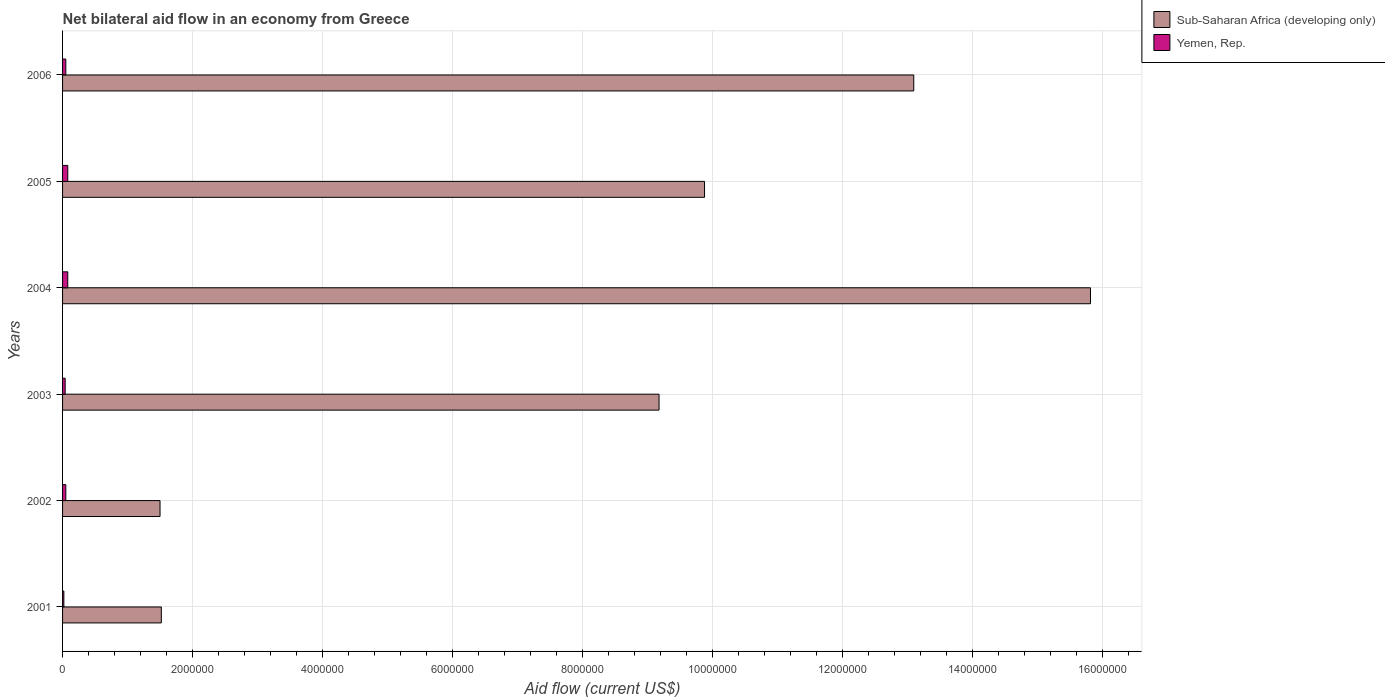How many different coloured bars are there?
Keep it short and to the point. 2. How many groups of bars are there?
Offer a terse response. 6. Are the number of bars per tick equal to the number of legend labels?
Provide a succinct answer. Yes. Are the number of bars on each tick of the Y-axis equal?
Provide a succinct answer. Yes. How many bars are there on the 4th tick from the top?
Your answer should be compact. 2. What is the label of the 1st group of bars from the top?
Provide a succinct answer. 2006. In how many cases, is the number of bars for a given year not equal to the number of legend labels?
Provide a succinct answer. 0. What is the net bilateral aid flow in Yemen, Rep. in 2006?
Offer a very short reply. 5.00e+04. Across all years, what is the maximum net bilateral aid flow in Sub-Saharan Africa (developing only)?
Your answer should be very brief. 1.58e+07. Across all years, what is the minimum net bilateral aid flow in Yemen, Rep.?
Your answer should be very brief. 2.00e+04. In which year was the net bilateral aid flow in Sub-Saharan Africa (developing only) maximum?
Offer a terse response. 2004. In which year was the net bilateral aid flow in Sub-Saharan Africa (developing only) minimum?
Your answer should be compact. 2002. What is the total net bilateral aid flow in Sub-Saharan Africa (developing only) in the graph?
Your answer should be compact. 5.10e+07. What is the difference between the net bilateral aid flow in Sub-Saharan Africa (developing only) in 2002 and that in 2003?
Provide a succinct answer. -7.68e+06. What is the difference between the net bilateral aid flow in Sub-Saharan Africa (developing only) in 2001 and the net bilateral aid flow in Yemen, Rep. in 2003?
Ensure brevity in your answer.  1.48e+06. What is the average net bilateral aid flow in Yemen, Rep. per year?
Keep it short and to the point. 5.33e+04. In the year 2002, what is the difference between the net bilateral aid flow in Yemen, Rep. and net bilateral aid flow in Sub-Saharan Africa (developing only)?
Ensure brevity in your answer.  -1.45e+06. What is the ratio of the net bilateral aid flow in Sub-Saharan Africa (developing only) in 2004 to that in 2006?
Keep it short and to the point. 1.21. Is the net bilateral aid flow in Yemen, Rep. in 2001 less than that in 2002?
Offer a very short reply. Yes. What is the difference between the highest and the second highest net bilateral aid flow in Yemen, Rep.?
Offer a very short reply. 0. Is the sum of the net bilateral aid flow in Sub-Saharan Africa (developing only) in 2003 and 2005 greater than the maximum net bilateral aid flow in Yemen, Rep. across all years?
Keep it short and to the point. Yes. What does the 1st bar from the top in 2004 represents?
Your answer should be very brief. Yemen, Rep. What does the 1st bar from the bottom in 2002 represents?
Provide a succinct answer. Sub-Saharan Africa (developing only). Are all the bars in the graph horizontal?
Give a very brief answer. Yes. How many years are there in the graph?
Keep it short and to the point. 6. What is the difference between two consecutive major ticks on the X-axis?
Offer a terse response. 2.00e+06. What is the title of the graph?
Provide a short and direct response. Net bilateral aid flow in an economy from Greece. Does "Venezuela" appear as one of the legend labels in the graph?
Provide a succinct answer. No. What is the label or title of the Y-axis?
Offer a terse response. Years. What is the Aid flow (current US$) in Sub-Saharan Africa (developing only) in 2001?
Provide a succinct answer. 1.52e+06. What is the Aid flow (current US$) in Sub-Saharan Africa (developing only) in 2002?
Keep it short and to the point. 1.50e+06. What is the Aid flow (current US$) in Sub-Saharan Africa (developing only) in 2003?
Your response must be concise. 9.18e+06. What is the Aid flow (current US$) in Sub-Saharan Africa (developing only) in 2004?
Provide a short and direct response. 1.58e+07. What is the Aid flow (current US$) of Sub-Saharan Africa (developing only) in 2005?
Your response must be concise. 9.88e+06. What is the Aid flow (current US$) in Sub-Saharan Africa (developing only) in 2006?
Your answer should be very brief. 1.31e+07. What is the Aid flow (current US$) in Yemen, Rep. in 2006?
Give a very brief answer. 5.00e+04. Across all years, what is the maximum Aid flow (current US$) in Sub-Saharan Africa (developing only)?
Your answer should be very brief. 1.58e+07. Across all years, what is the maximum Aid flow (current US$) of Yemen, Rep.?
Ensure brevity in your answer.  8.00e+04. Across all years, what is the minimum Aid flow (current US$) in Sub-Saharan Africa (developing only)?
Offer a terse response. 1.50e+06. What is the total Aid flow (current US$) of Sub-Saharan Africa (developing only) in the graph?
Your answer should be very brief. 5.10e+07. What is the difference between the Aid flow (current US$) in Sub-Saharan Africa (developing only) in 2001 and that in 2003?
Your answer should be very brief. -7.66e+06. What is the difference between the Aid flow (current US$) of Sub-Saharan Africa (developing only) in 2001 and that in 2004?
Your response must be concise. -1.43e+07. What is the difference between the Aid flow (current US$) of Yemen, Rep. in 2001 and that in 2004?
Give a very brief answer. -6.00e+04. What is the difference between the Aid flow (current US$) of Sub-Saharan Africa (developing only) in 2001 and that in 2005?
Your answer should be very brief. -8.36e+06. What is the difference between the Aid flow (current US$) in Yemen, Rep. in 2001 and that in 2005?
Make the answer very short. -6.00e+04. What is the difference between the Aid flow (current US$) of Sub-Saharan Africa (developing only) in 2001 and that in 2006?
Make the answer very short. -1.16e+07. What is the difference between the Aid flow (current US$) in Yemen, Rep. in 2001 and that in 2006?
Make the answer very short. -3.00e+04. What is the difference between the Aid flow (current US$) in Sub-Saharan Africa (developing only) in 2002 and that in 2003?
Offer a very short reply. -7.68e+06. What is the difference between the Aid flow (current US$) of Yemen, Rep. in 2002 and that in 2003?
Make the answer very short. 10000. What is the difference between the Aid flow (current US$) in Sub-Saharan Africa (developing only) in 2002 and that in 2004?
Offer a terse response. -1.43e+07. What is the difference between the Aid flow (current US$) in Yemen, Rep. in 2002 and that in 2004?
Make the answer very short. -3.00e+04. What is the difference between the Aid flow (current US$) in Sub-Saharan Africa (developing only) in 2002 and that in 2005?
Provide a succinct answer. -8.38e+06. What is the difference between the Aid flow (current US$) in Yemen, Rep. in 2002 and that in 2005?
Ensure brevity in your answer.  -3.00e+04. What is the difference between the Aid flow (current US$) in Sub-Saharan Africa (developing only) in 2002 and that in 2006?
Your response must be concise. -1.16e+07. What is the difference between the Aid flow (current US$) in Sub-Saharan Africa (developing only) in 2003 and that in 2004?
Give a very brief answer. -6.64e+06. What is the difference between the Aid flow (current US$) in Yemen, Rep. in 2003 and that in 2004?
Provide a short and direct response. -4.00e+04. What is the difference between the Aid flow (current US$) in Sub-Saharan Africa (developing only) in 2003 and that in 2005?
Offer a terse response. -7.00e+05. What is the difference between the Aid flow (current US$) in Yemen, Rep. in 2003 and that in 2005?
Your response must be concise. -4.00e+04. What is the difference between the Aid flow (current US$) of Sub-Saharan Africa (developing only) in 2003 and that in 2006?
Keep it short and to the point. -3.92e+06. What is the difference between the Aid flow (current US$) of Sub-Saharan Africa (developing only) in 2004 and that in 2005?
Ensure brevity in your answer.  5.94e+06. What is the difference between the Aid flow (current US$) in Yemen, Rep. in 2004 and that in 2005?
Provide a succinct answer. 0. What is the difference between the Aid flow (current US$) in Sub-Saharan Africa (developing only) in 2004 and that in 2006?
Give a very brief answer. 2.72e+06. What is the difference between the Aid flow (current US$) of Yemen, Rep. in 2004 and that in 2006?
Ensure brevity in your answer.  3.00e+04. What is the difference between the Aid flow (current US$) in Sub-Saharan Africa (developing only) in 2005 and that in 2006?
Make the answer very short. -3.22e+06. What is the difference between the Aid flow (current US$) in Sub-Saharan Africa (developing only) in 2001 and the Aid flow (current US$) in Yemen, Rep. in 2002?
Provide a short and direct response. 1.47e+06. What is the difference between the Aid flow (current US$) of Sub-Saharan Africa (developing only) in 2001 and the Aid flow (current US$) of Yemen, Rep. in 2003?
Ensure brevity in your answer.  1.48e+06. What is the difference between the Aid flow (current US$) in Sub-Saharan Africa (developing only) in 2001 and the Aid flow (current US$) in Yemen, Rep. in 2004?
Make the answer very short. 1.44e+06. What is the difference between the Aid flow (current US$) in Sub-Saharan Africa (developing only) in 2001 and the Aid flow (current US$) in Yemen, Rep. in 2005?
Offer a very short reply. 1.44e+06. What is the difference between the Aid flow (current US$) in Sub-Saharan Africa (developing only) in 2001 and the Aid flow (current US$) in Yemen, Rep. in 2006?
Give a very brief answer. 1.47e+06. What is the difference between the Aid flow (current US$) of Sub-Saharan Africa (developing only) in 2002 and the Aid flow (current US$) of Yemen, Rep. in 2003?
Offer a very short reply. 1.46e+06. What is the difference between the Aid flow (current US$) of Sub-Saharan Africa (developing only) in 2002 and the Aid flow (current US$) of Yemen, Rep. in 2004?
Give a very brief answer. 1.42e+06. What is the difference between the Aid flow (current US$) in Sub-Saharan Africa (developing only) in 2002 and the Aid flow (current US$) in Yemen, Rep. in 2005?
Your answer should be compact. 1.42e+06. What is the difference between the Aid flow (current US$) in Sub-Saharan Africa (developing only) in 2002 and the Aid flow (current US$) in Yemen, Rep. in 2006?
Your answer should be compact. 1.45e+06. What is the difference between the Aid flow (current US$) in Sub-Saharan Africa (developing only) in 2003 and the Aid flow (current US$) in Yemen, Rep. in 2004?
Give a very brief answer. 9.10e+06. What is the difference between the Aid flow (current US$) in Sub-Saharan Africa (developing only) in 2003 and the Aid flow (current US$) in Yemen, Rep. in 2005?
Offer a very short reply. 9.10e+06. What is the difference between the Aid flow (current US$) in Sub-Saharan Africa (developing only) in 2003 and the Aid flow (current US$) in Yemen, Rep. in 2006?
Give a very brief answer. 9.13e+06. What is the difference between the Aid flow (current US$) in Sub-Saharan Africa (developing only) in 2004 and the Aid flow (current US$) in Yemen, Rep. in 2005?
Give a very brief answer. 1.57e+07. What is the difference between the Aid flow (current US$) in Sub-Saharan Africa (developing only) in 2004 and the Aid flow (current US$) in Yemen, Rep. in 2006?
Ensure brevity in your answer.  1.58e+07. What is the difference between the Aid flow (current US$) in Sub-Saharan Africa (developing only) in 2005 and the Aid flow (current US$) in Yemen, Rep. in 2006?
Your answer should be compact. 9.83e+06. What is the average Aid flow (current US$) in Sub-Saharan Africa (developing only) per year?
Give a very brief answer. 8.50e+06. What is the average Aid flow (current US$) of Yemen, Rep. per year?
Make the answer very short. 5.33e+04. In the year 2001, what is the difference between the Aid flow (current US$) in Sub-Saharan Africa (developing only) and Aid flow (current US$) in Yemen, Rep.?
Ensure brevity in your answer.  1.50e+06. In the year 2002, what is the difference between the Aid flow (current US$) in Sub-Saharan Africa (developing only) and Aid flow (current US$) in Yemen, Rep.?
Offer a very short reply. 1.45e+06. In the year 2003, what is the difference between the Aid flow (current US$) in Sub-Saharan Africa (developing only) and Aid flow (current US$) in Yemen, Rep.?
Provide a succinct answer. 9.14e+06. In the year 2004, what is the difference between the Aid flow (current US$) of Sub-Saharan Africa (developing only) and Aid flow (current US$) of Yemen, Rep.?
Keep it short and to the point. 1.57e+07. In the year 2005, what is the difference between the Aid flow (current US$) of Sub-Saharan Africa (developing only) and Aid flow (current US$) of Yemen, Rep.?
Offer a terse response. 9.80e+06. In the year 2006, what is the difference between the Aid flow (current US$) of Sub-Saharan Africa (developing only) and Aid flow (current US$) of Yemen, Rep.?
Make the answer very short. 1.30e+07. What is the ratio of the Aid flow (current US$) of Sub-Saharan Africa (developing only) in 2001 to that in 2002?
Your answer should be very brief. 1.01. What is the ratio of the Aid flow (current US$) in Sub-Saharan Africa (developing only) in 2001 to that in 2003?
Your answer should be compact. 0.17. What is the ratio of the Aid flow (current US$) of Sub-Saharan Africa (developing only) in 2001 to that in 2004?
Make the answer very short. 0.1. What is the ratio of the Aid flow (current US$) in Sub-Saharan Africa (developing only) in 2001 to that in 2005?
Give a very brief answer. 0.15. What is the ratio of the Aid flow (current US$) of Sub-Saharan Africa (developing only) in 2001 to that in 2006?
Provide a succinct answer. 0.12. What is the ratio of the Aid flow (current US$) of Sub-Saharan Africa (developing only) in 2002 to that in 2003?
Keep it short and to the point. 0.16. What is the ratio of the Aid flow (current US$) in Sub-Saharan Africa (developing only) in 2002 to that in 2004?
Offer a terse response. 0.09. What is the ratio of the Aid flow (current US$) in Yemen, Rep. in 2002 to that in 2004?
Offer a terse response. 0.62. What is the ratio of the Aid flow (current US$) in Sub-Saharan Africa (developing only) in 2002 to that in 2005?
Provide a short and direct response. 0.15. What is the ratio of the Aid flow (current US$) in Yemen, Rep. in 2002 to that in 2005?
Provide a short and direct response. 0.62. What is the ratio of the Aid flow (current US$) in Sub-Saharan Africa (developing only) in 2002 to that in 2006?
Your answer should be compact. 0.11. What is the ratio of the Aid flow (current US$) of Yemen, Rep. in 2002 to that in 2006?
Your answer should be very brief. 1. What is the ratio of the Aid flow (current US$) in Sub-Saharan Africa (developing only) in 2003 to that in 2004?
Give a very brief answer. 0.58. What is the ratio of the Aid flow (current US$) of Sub-Saharan Africa (developing only) in 2003 to that in 2005?
Your answer should be compact. 0.93. What is the ratio of the Aid flow (current US$) of Sub-Saharan Africa (developing only) in 2003 to that in 2006?
Provide a succinct answer. 0.7. What is the ratio of the Aid flow (current US$) of Sub-Saharan Africa (developing only) in 2004 to that in 2005?
Keep it short and to the point. 1.6. What is the ratio of the Aid flow (current US$) of Yemen, Rep. in 2004 to that in 2005?
Your answer should be compact. 1. What is the ratio of the Aid flow (current US$) in Sub-Saharan Africa (developing only) in 2004 to that in 2006?
Ensure brevity in your answer.  1.21. What is the ratio of the Aid flow (current US$) of Sub-Saharan Africa (developing only) in 2005 to that in 2006?
Offer a terse response. 0.75. What is the difference between the highest and the second highest Aid flow (current US$) of Sub-Saharan Africa (developing only)?
Offer a very short reply. 2.72e+06. What is the difference between the highest and the lowest Aid flow (current US$) of Sub-Saharan Africa (developing only)?
Ensure brevity in your answer.  1.43e+07. 